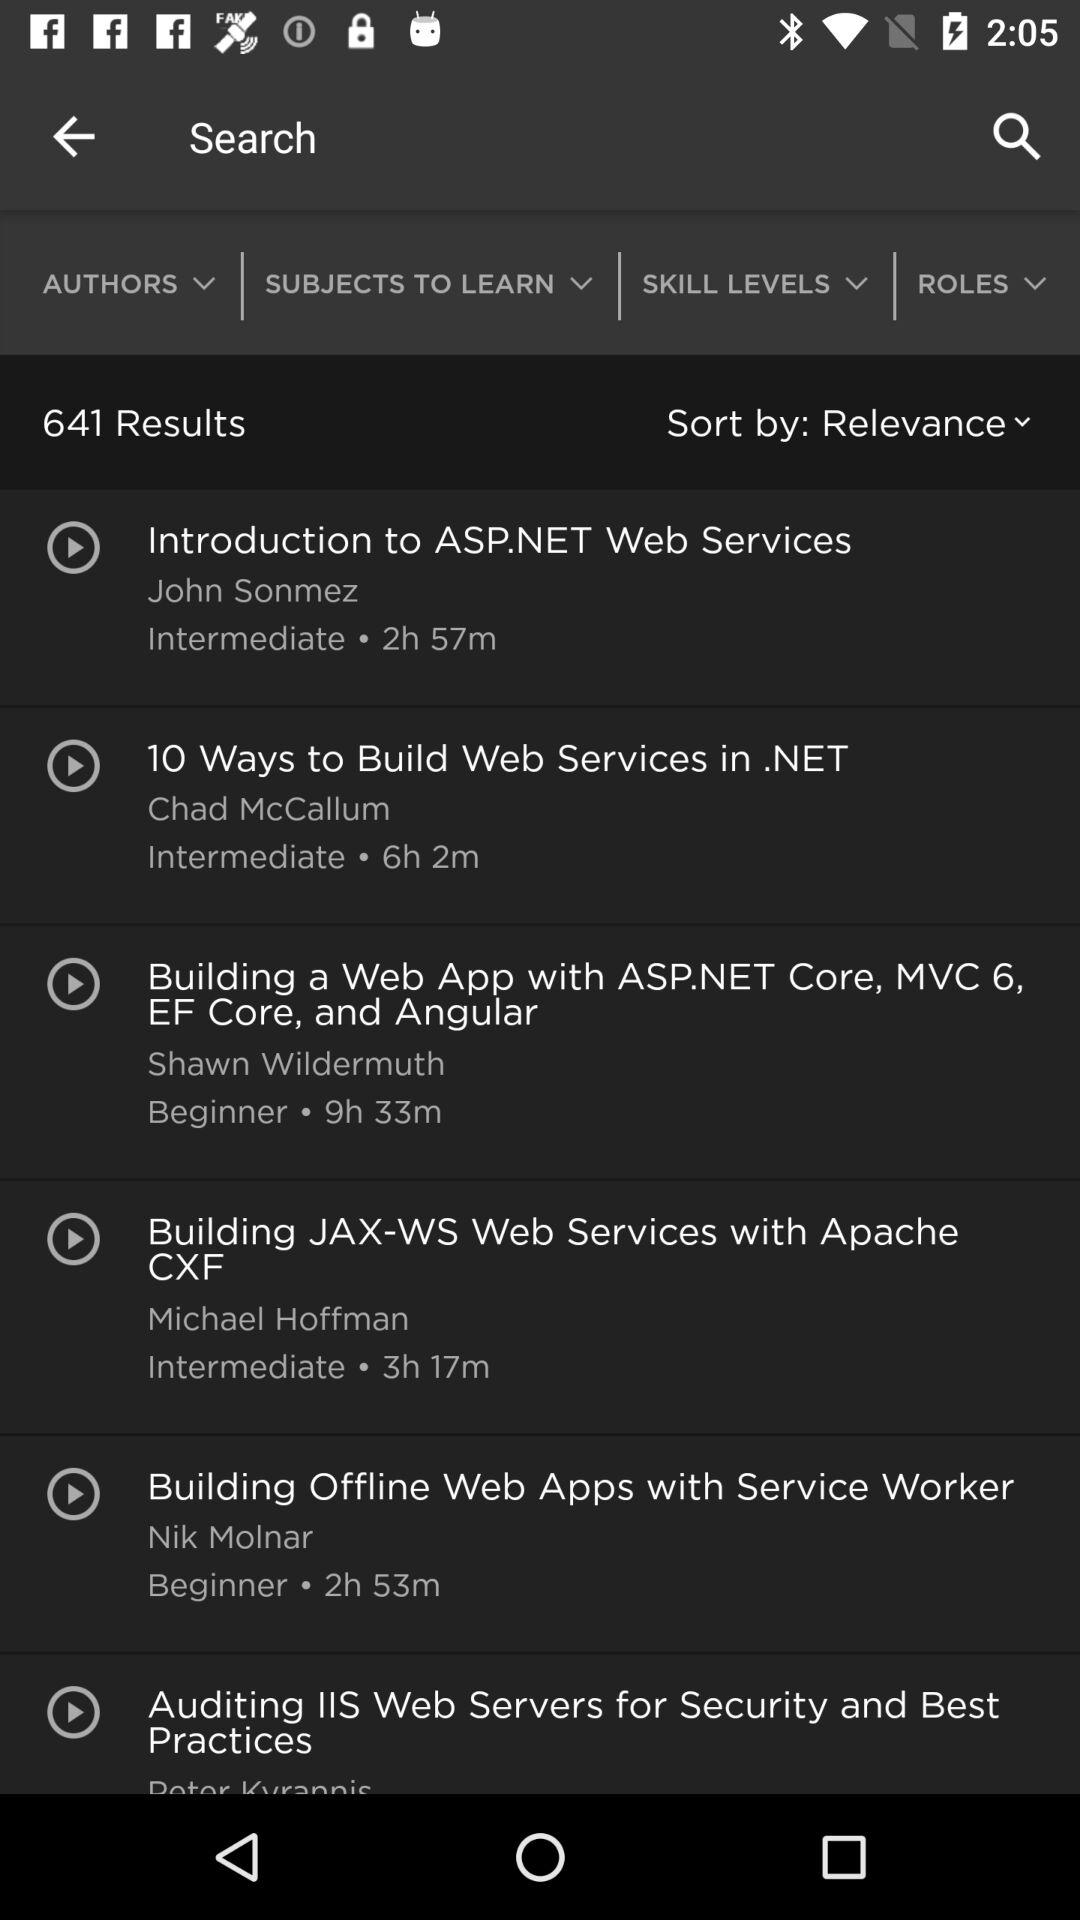What is the duration of "10 Ways to Build Web Services in.NET"? The duration of "10 Ways to Build Web Services in.NET" is 6 hours 2 minutes. 